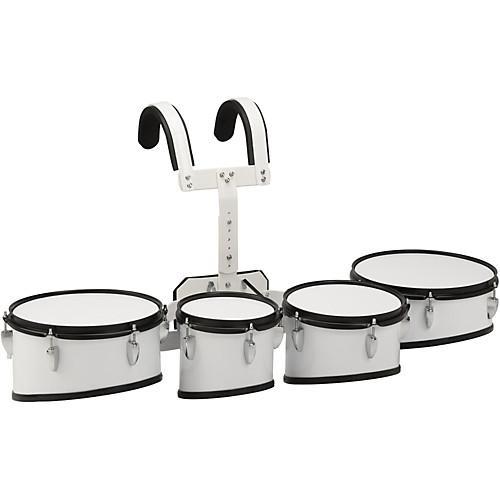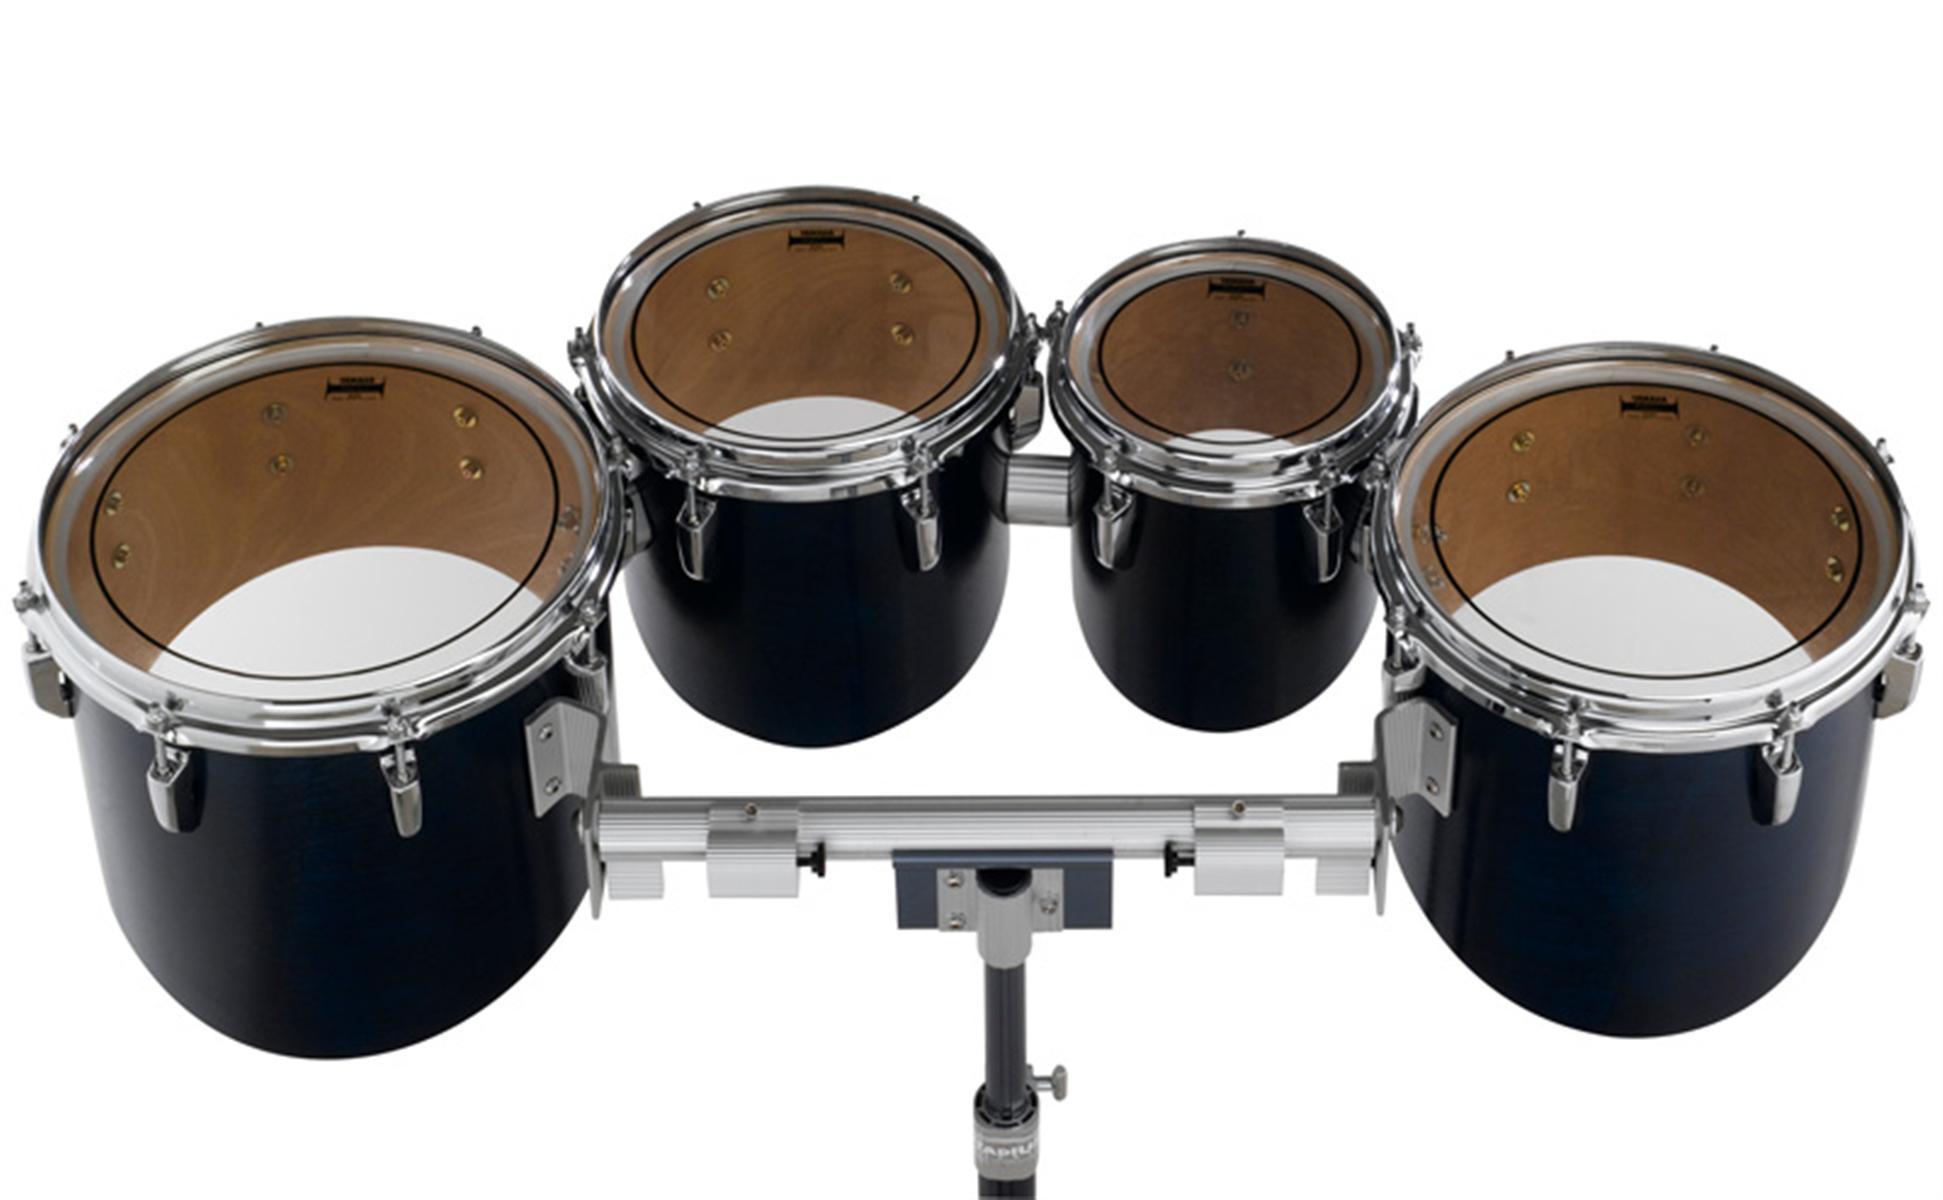The first image is the image on the left, the second image is the image on the right. Given the left and right images, does the statement "At least one kit contains more than four drums." hold true? Answer yes or no. No. The first image is the image on the left, the second image is the image on the right. For the images displayed, is the sentence "The drum base is white in the left image." factually correct? Answer yes or no. Yes. 